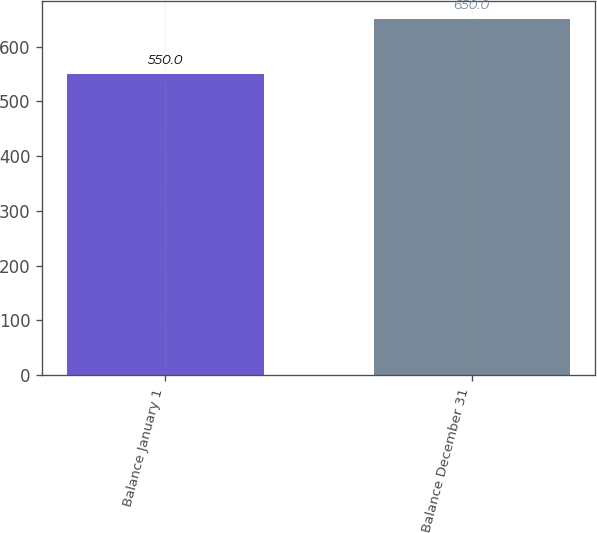Convert chart to OTSL. <chart><loc_0><loc_0><loc_500><loc_500><bar_chart><fcel>Balance January 1<fcel>Balance December 31<nl><fcel>550<fcel>650<nl></chart> 